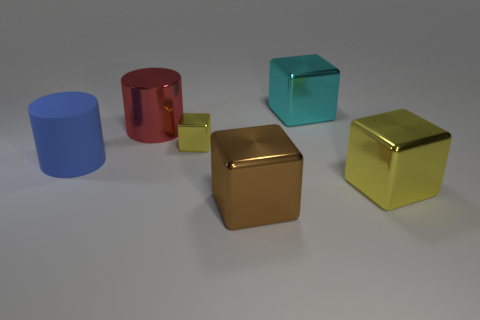Subtract all cyan cubes. How many cubes are left? 3 Subtract all cyan shiny blocks. How many blocks are left? 3 Add 3 small red rubber spheres. How many objects exist? 9 Subtract all gray cubes. Subtract all blue cylinders. How many cubes are left? 4 Subtract all blocks. How many objects are left? 2 Subtract all small brown metallic objects. Subtract all red shiny things. How many objects are left? 5 Add 1 yellow metal cubes. How many yellow metal cubes are left? 3 Add 4 large blue matte objects. How many large blue matte objects exist? 5 Subtract 0 blue balls. How many objects are left? 6 